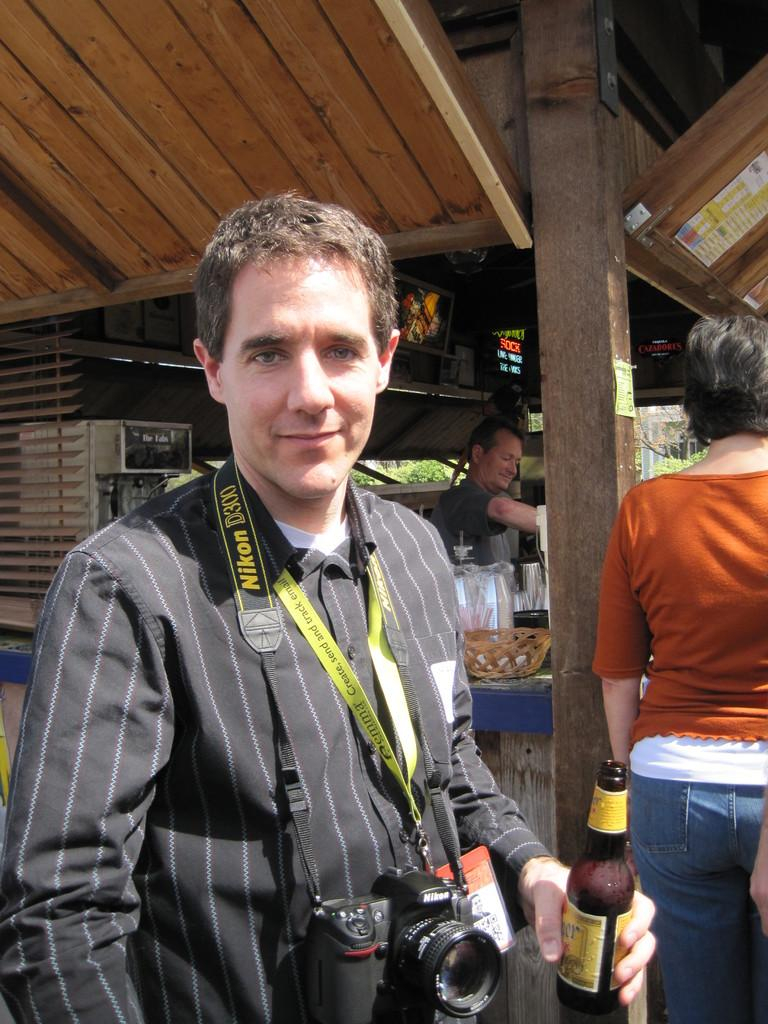What is the person in the image carrying around their neck? The person is carrying a camera around their neck. What is the person holding in their hand? The person is holding a wine bottle in their hand. Can you describe the person standing behind the first person? There is another person behind the first person. What is the gender of the person standing behind the first person? There is a woman standing behind the first person. What type of drug is the person in the image using? There is no indication in the image that the person is using any drugs. 